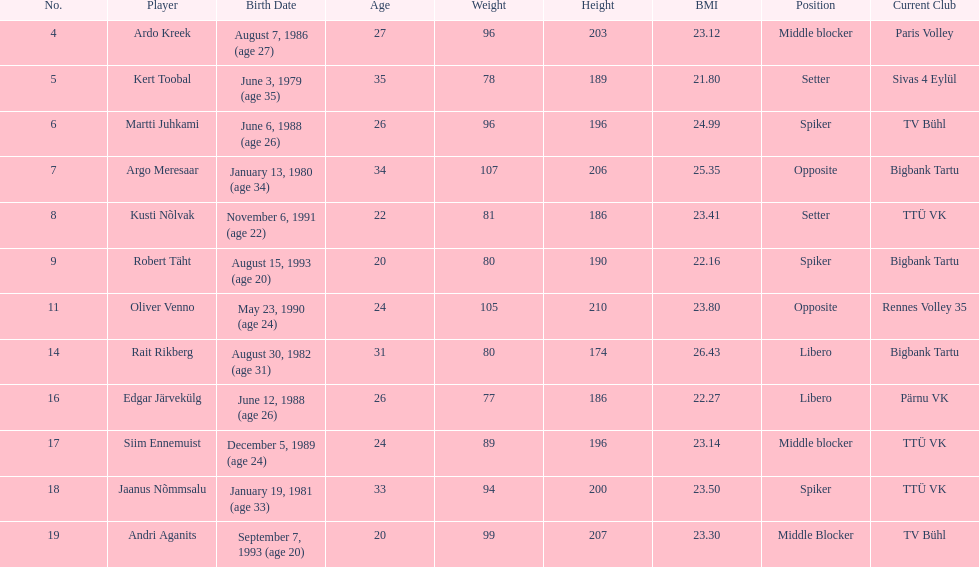How many members of estonia's men's national volleyball team were born in 1988? 2. 